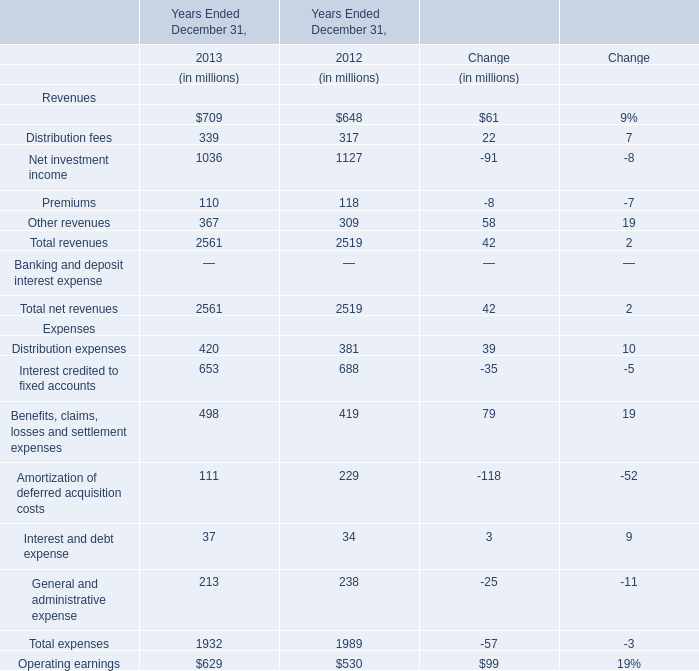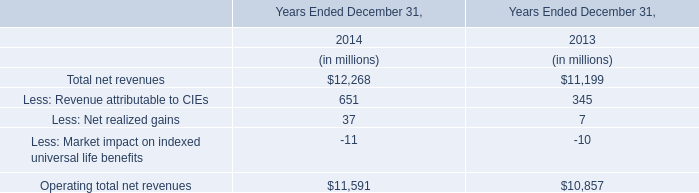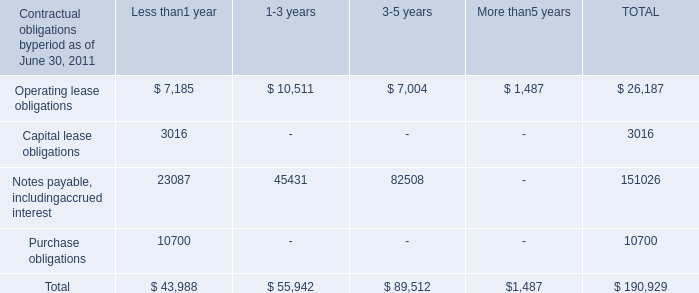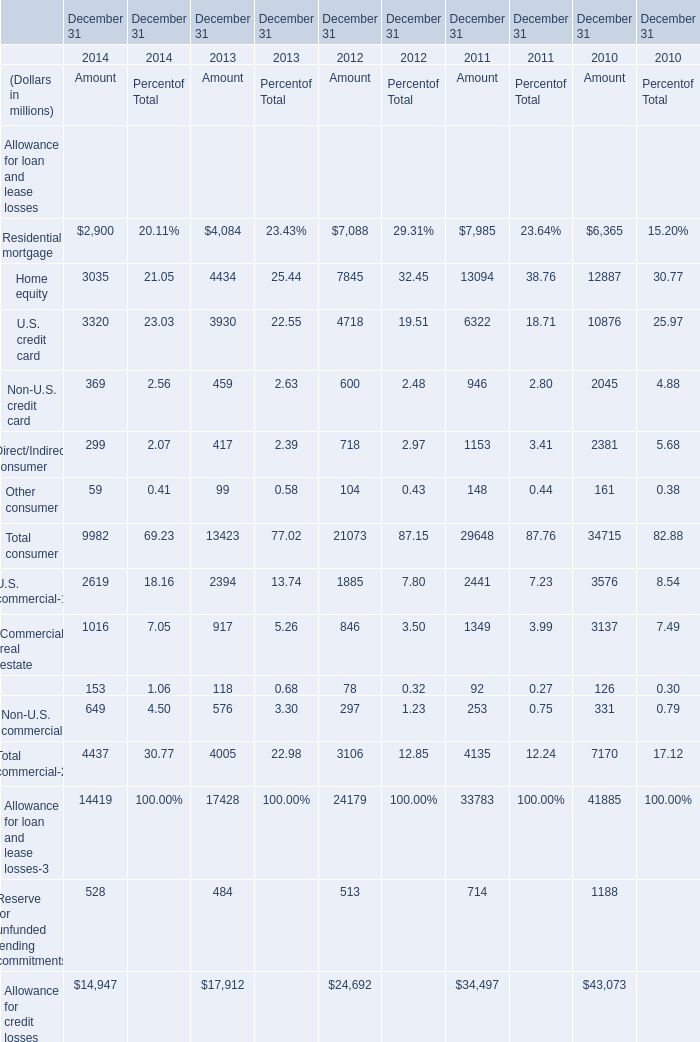What is the average amount of U.S. credit card of December 31 2012 Amount, and Purchase obligations of Less than1 year ? 
Computations: ((4718.0 + 10700.0) / 2)
Answer: 7709.0. 